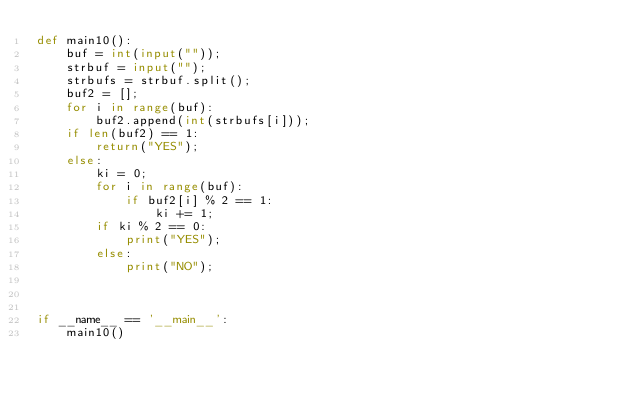<code> <loc_0><loc_0><loc_500><loc_500><_Python_>def main10():
    buf = int(input(""));
    strbuf = input("");
    strbufs = strbuf.split();
    buf2 = [];
    for i in range(buf):
        buf2.append(int(strbufs[i]));
    if len(buf2) == 1:
        return("YES");
    else:
        ki = 0;
        for i in range(buf):
            if buf2[i] % 2 == 1:
                ki += 1;
        if ki % 2 == 0:
            print("YES");
        else:
            print("NO");



if __name__ == '__main__':
    main10()</code> 